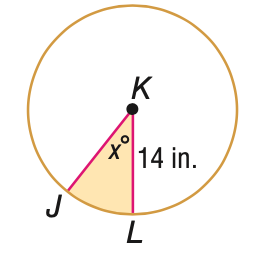Question: The area A of the shaded region is given. Find x. A = 94 in^2.
Choices:
A. 5.5
B. 27.5
C. 55.0
D. 110.0
Answer with the letter. Answer: C 